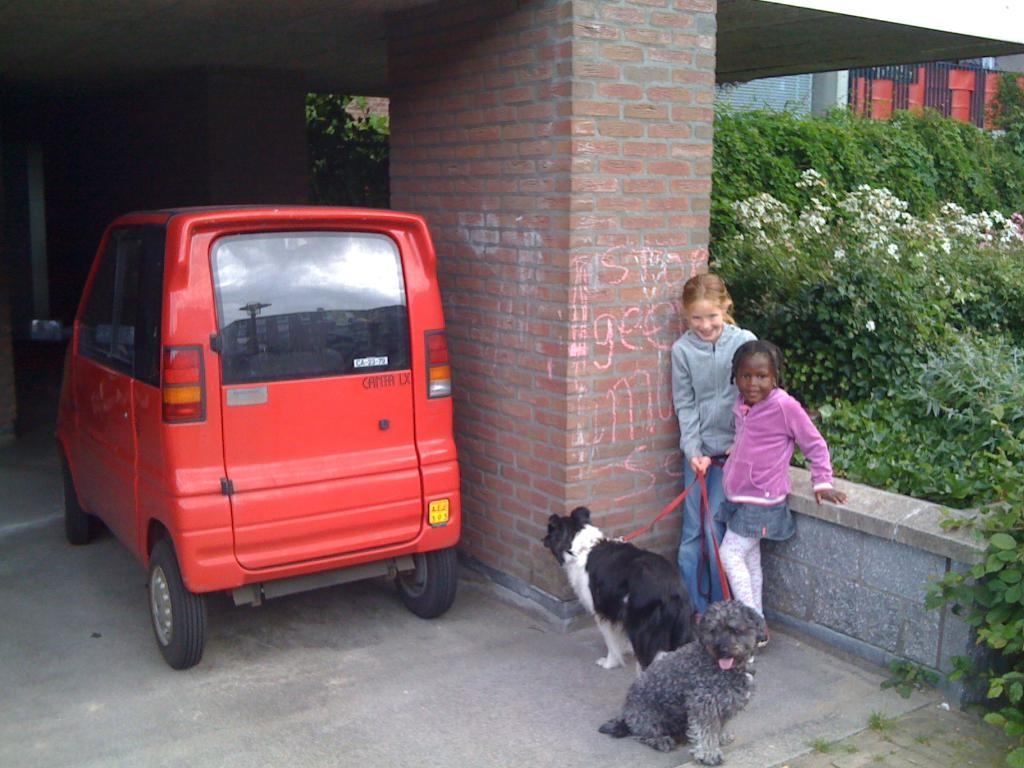What is located beside the pillar in the image? There is a vehicle beside the pillar in the image. How many girls are in the image? There are two girls in the image. What is the facial expression of the girls? The girls are smiling. What are the girls holding in the image? The girls are holding two dogs with ropes. What can be seen in the background of the image? There is a building and trees in the background of the image. What type of knife is being used to cut the bushes in the image? There is no knife or bushes present in the image. What kind of bait is being used to attract the dogs in the image? There is no bait present in the image; the girls are holding the dogs with ropes. 